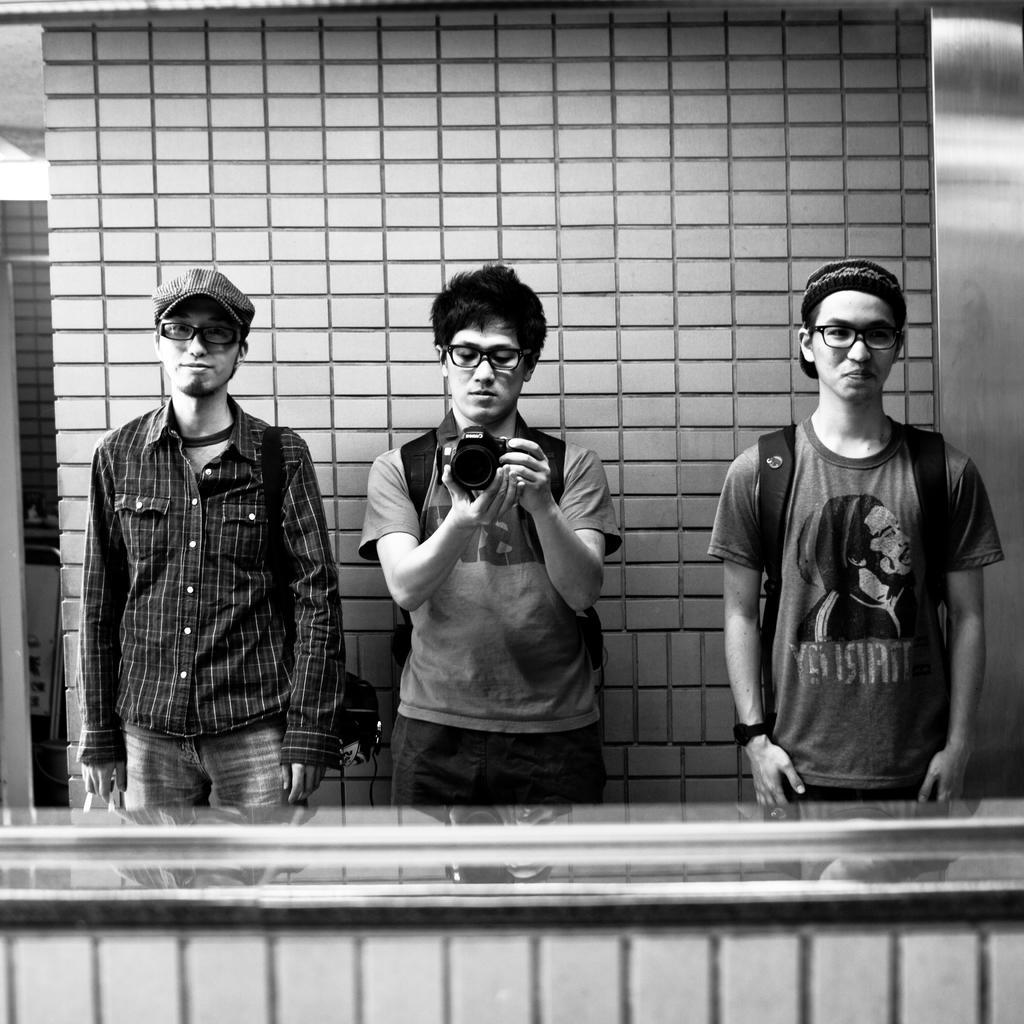Could you give a brief overview of what you see in this image? It is the black and white image in which there are three men in the middle. The man in the middle is holding the camera. In the background there is a wall. The man on the right side is wearing the bag and a cap. 